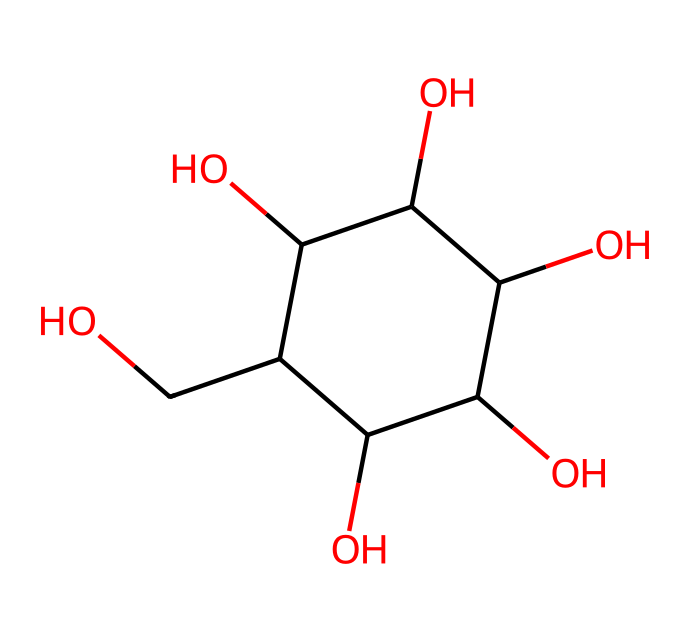What is the molecular formula of glucose? To determine the molecular formula, we analyze the structure represented in the SMILES notation. The structure shows six carbons (C), twelve hydrogens (H), and six oxygens (O), leading to the formula C6H12O6.
Answer: C6H12O6 How many hydroxyl (-OH) groups are present in the structure? By examining the chemical structure, we can identify that each of the five carbon atoms (not the one in the ring) is adjacent to a hydroxyl group. Since glucose has five -OH groups, we conclude that there are five present.
Answer: 5 What type of carbohydrate is glucose classified as? Glucose is a simple sugar or monosaccharide, as it consists of a single sugar unit and cannot be hydrolyzed into smaller carbohydrate units. This classification is standard in carbohydrate chemistry.
Answer: monosaccharide What is the total number of carbon atoms in glucose? The structure indicates that there are six carbon atoms (C). Counting directly from the representation leads us to this conclusion.
Answer: 6 What is the predominant functional group in the structure of glucose? The structure shows multiple hydroxyl (-OH) groups which are characteristic of alcohols; hence, the predominant functional group in glucose is the hydroxyl group. Multiple -OH groups indicate it's a polyalcohol.
Answer: hydroxyl What kind of isomerism can glucose exhibit? Glucose can exhibit isomerism due to its structure. It can exist in different forms, such as α and β anomers, due to the orientation of the hydroxyl group on the anomeric carbon. This relates to the specific configuration of the sugar's cyclic form.
Answer: anomerism 